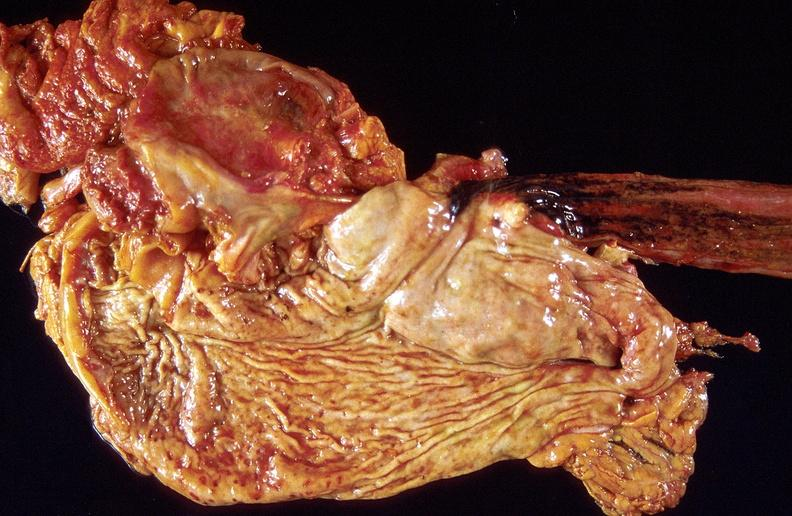s gastrointestinal present?
Answer the question using a single word or phrase. Yes 